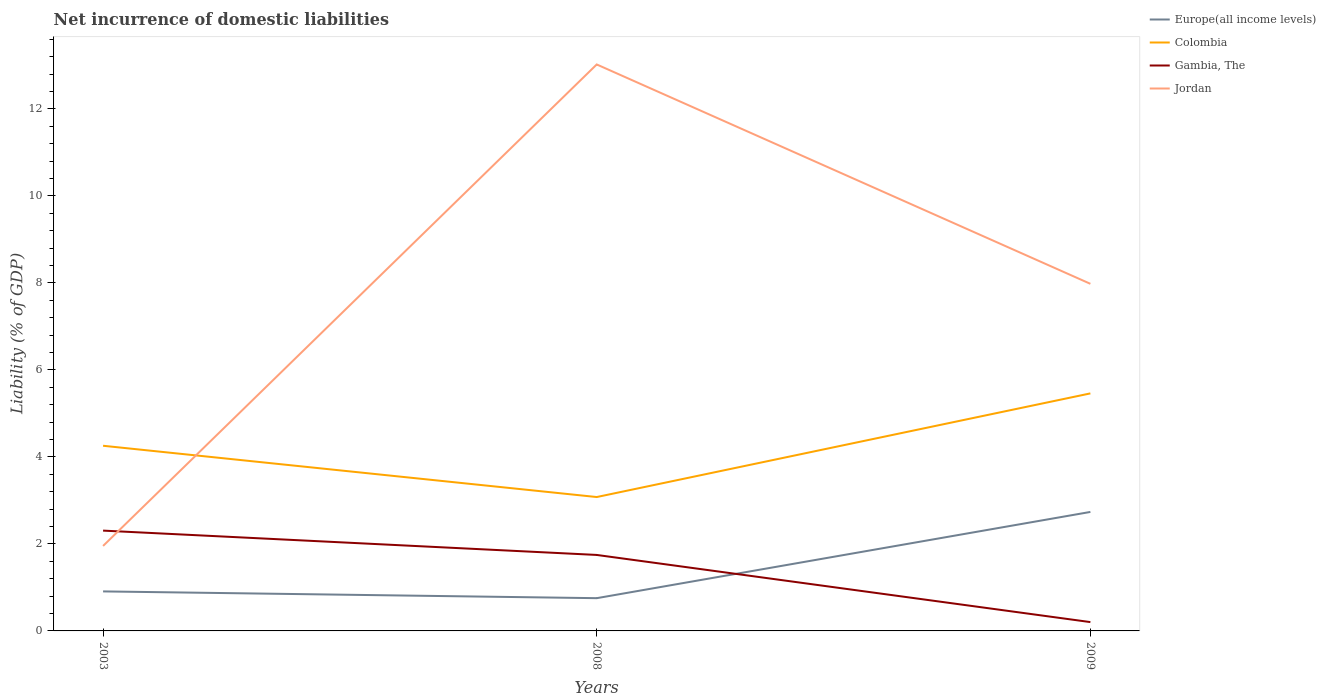Across all years, what is the maximum net incurrence of domestic liabilities in Jordan?
Your answer should be very brief. 1.95. In which year was the net incurrence of domestic liabilities in Jordan maximum?
Offer a terse response. 2003. What is the total net incurrence of domestic liabilities in Colombia in the graph?
Keep it short and to the point. 1.18. What is the difference between the highest and the second highest net incurrence of domestic liabilities in Colombia?
Your response must be concise. 2.38. Is the net incurrence of domestic liabilities in Europe(all income levels) strictly greater than the net incurrence of domestic liabilities in Jordan over the years?
Offer a terse response. Yes. Does the graph contain any zero values?
Keep it short and to the point. No. Where does the legend appear in the graph?
Your answer should be very brief. Top right. How many legend labels are there?
Offer a very short reply. 4. How are the legend labels stacked?
Give a very brief answer. Vertical. What is the title of the graph?
Ensure brevity in your answer.  Net incurrence of domestic liabilities. Does "Lower middle income" appear as one of the legend labels in the graph?
Make the answer very short. No. What is the label or title of the X-axis?
Keep it short and to the point. Years. What is the label or title of the Y-axis?
Make the answer very short. Liability (% of GDP). What is the Liability (% of GDP) in Europe(all income levels) in 2003?
Keep it short and to the point. 0.91. What is the Liability (% of GDP) in Colombia in 2003?
Your answer should be very brief. 4.26. What is the Liability (% of GDP) of Gambia, The in 2003?
Ensure brevity in your answer.  2.31. What is the Liability (% of GDP) in Jordan in 2003?
Ensure brevity in your answer.  1.95. What is the Liability (% of GDP) in Europe(all income levels) in 2008?
Your answer should be compact. 0.75. What is the Liability (% of GDP) of Colombia in 2008?
Make the answer very short. 3.08. What is the Liability (% of GDP) in Gambia, The in 2008?
Your answer should be very brief. 1.75. What is the Liability (% of GDP) of Jordan in 2008?
Offer a terse response. 13.02. What is the Liability (% of GDP) of Europe(all income levels) in 2009?
Your answer should be compact. 2.74. What is the Liability (% of GDP) of Colombia in 2009?
Your response must be concise. 5.46. What is the Liability (% of GDP) in Gambia, The in 2009?
Your response must be concise. 0.2. What is the Liability (% of GDP) of Jordan in 2009?
Keep it short and to the point. 7.98. Across all years, what is the maximum Liability (% of GDP) of Europe(all income levels)?
Offer a very short reply. 2.74. Across all years, what is the maximum Liability (% of GDP) of Colombia?
Provide a short and direct response. 5.46. Across all years, what is the maximum Liability (% of GDP) in Gambia, The?
Offer a very short reply. 2.31. Across all years, what is the maximum Liability (% of GDP) in Jordan?
Your response must be concise. 13.02. Across all years, what is the minimum Liability (% of GDP) in Europe(all income levels)?
Ensure brevity in your answer.  0.75. Across all years, what is the minimum Liability (% of GDP) of Colombia?
Ensure brevity in your answer.  3.08. Across all years, what is the minimum Liability (% of GDP) of Gambia, The?
Give a very brief answer. 0.2. Across all years, what is the minimum Liability (% of GDP) in Jordan?
Offer a very short reply. 1.95. What is the total Liability (% of GDP) of Europe(all income levels) in the graph?
Your answer should be compact. 4.4. What is the total Liability (% of GDP) in Colombia in the graph?
Provide a succinct answer. 12.8. What is the total Liability (% of GDP) in Gambia, The in the graph?
Offer a terse response. 4.26. What is the total Liability (% of GDP) in Jordan in the graph?
Your response must be concise. 22.96. What is the difference between the Liability (% of GDP) of Europe(all income levels) in 2003 and that in 2008?
Keep it short and to the point. 0.16. What is the difference between the Liability (% of GDP) in Colombia in 2003 and that in 2008?
Ensure brevity in your answer.  1.18. What is the difference between the Liability (% of GDP) of Gambia, The in 2003 and that in 2008?
Provide a short and direct response. 0.56. What is the difference between the Liability (% of GDP) in Jordan in 2003 and that in 2008?
Your answer should be compact. -11.07. What is the difference between the Liability (% of GDP) in Europe(all income levels) in 2003 and that in 2009?
Offer a very short reply. -1.83. What is the difference between the Liability (% of GDP) of Colombia in 2003 and that in 2009?
Provide a succinct answer. -1.2. What is the difference between the Liability (% of GDP) of Gambia, The in 2003 and that in 2009?
Make the answer very short. 2.1. What is the difference between the Liability (% of GDP) of Jordan in 2003 and that in 2009?
Provide a succinct answer. -6.03. What is the difference between the Liability (% of GDP) in Europe(all income levels) in 2008 and that in 2009?
Your answer should be compact. -1.98. What is the difference between the Liability (% of GDP) of Colombia in 2008 and that in 2009?
Offer a terse response. -2.38. What is the difference between the Liability (% of GDP) in Gambia, The in 2008 and that in 2009?
Your response must be concise. 1.54. What is the difference between the Liability (% of GDP) in Jordan in 2008 and that in 2009?
Give a very brief answer. 5.04. What is the difference between the Liability (% of GDP) of Europe(all income levels) in 2003 and the Liability (% of GDP) of Colombia in 2008?
Keep it short and to the point. -2.17. What is the difference between the Liability (% of GDP) in Europe(all income levels) in 2003 and the Liability (% of GDP) in Gambia, The in 2008?
Your answer should be very brief. -0.84. What is the difference between the Liability (% of GDP) of Europe(all income levels) in 2003 and the Liability (% of GDP) of Jordan in 2008?
Your response must be concise. -12.12. What is the difference between the Liability (% of GDP) of Colombia in 2003 and the Liability (% of GDP) of Gambia, The in 2008?
Provide a succinct answer. 2.51. What is the difference between the Liability (% of GDP) in Colombia in 2003 and the Liability (% of GDP) in Jordan in 2008?
Provide a short and direct response. -8.77. What is the difference between the Liability (% of GDP) of Gambia, The in 2003 and the Liability (% of GDP) of Jordan in 2008?
Provide a short and direct response. -10.72. What is the difference between the Liability (% of GDP) in Europe(all income levels) in 2003 and the Liability (% of GDP) in Colombia in 2009?
Provide a succinct answer. -4.55. What is the difference between the Liability (% of GDP) in Europe(all income levels) in 2003 and the Liability (% of GDP) in Gambia, The in 2009?
Offer a very short reply. 0.71. What is the difference between the Liability (% of GDP) of Europe(all income levels) in 2003 and the Liability (% of GDP) of Jordan in 2009?
Keep it short and to the point. -7.07. What is the difference between the Liability (% of GDP) in Colombia in 2003 and the Liability (% of GDP) in Gambia, The in 2009?
Provide a short and direct response. 4.05. What is the difference between the Liability (% of GDP) of Colombia in 2003 and the Liability (% of GDP) of Jordan in 2009?
Provide a succinct answer. -3.72. What is the difference between the Liability (% of GDP) of Gambia, The in 2003 and the Liability (% of GDP) of Jordan in 2009?
Make the answer very short. -5.67. What is the difference between the Liability (% of GDP) in Europe(all income levels) in 2008 and the Liability (% of GDP) in Colombia in 2009?
Make the answer very short. -4.71. What is the difference between the Liability (% of GDP) in Europe(all income levels) in 2008 and the Liability (% of GDP) in Gambia, The in 2009?
Your answer should be very brief. 0.55. What is the difference between the Liability (% of GDP) of Europe(all income levels) in 2008 and the Liability (% of GDP) of Jordan in 2009?
Ensure brevity in your answer.  -7.23. What is the difference between the Liability (% of GDP) in Colombia in 2008 and the Liability (% of GDP) in Gambia, The in 2009?
Your response must be concise. 2.88. What is the difference between the Liability (% of GDP) of Colombia in 2008 and the Liability (% of GDP) of Jordan in 2009?
Provide a short and direct response. -4.9. What is the difference between the Liability (% of GDP) of Gambia, The in 2008 and the Liability (% of GDP) of Jordan in 2009?
Your answer should be very brief. -6.23. What is the average Liability (% of GDP) in Europe(all income levels) per year?
Give a very brief answer. 1.47. What is the average Liability (% of GDP) in Colombia per year?
Your answer should be very brief. 4.27. What is the average Liability (% of GDP) in Gambia, The per year?
Provide a short and direct response. 1.42. What is the average Liability (% of GDP) in Jordan per year?
Keep it short and to the point. 7.65. In the year 2003, what is the difference between the Liability (% of GDP) of Europe(all income levels) and Liability (% of GDP) of Colombia?
Your answer should be compact. -3.35. In the year 2003, what is the difference between the Liability (% of GDP) of Europe(all income levels) and Liability (% of GDP) of Gambia, The?
Provide a succinct answer. -1.4. In the year 2003, what is the difference between the Liability (% of GDP) in Europe(all income levels) and Liability (% of GDP) in Jordan?
Offer a terse response. -1.05. In the year 2003, what is the difference between the Liability (% of GDP) in Colombia and Liability (% of GDP) in Gambia, The?
Offer a terse response. 1.95. In the year 2003, what is the difference between the Liability (% of GDP) in Colombia and Liability (% of GDP) in Jordan?
Your answer should be very brief. 2.3. In the year 2003, what is the difference between the Liability (% of GDP) of Gambia, The and Liability (% of GDP) of Jordan?
Your response must be concise. 0.35. In the year 2008, what is the difference between the Liability (% of GDP) in Europe(all income levels) and Liability (% of GDP) in Colombia?
Your answer should be compact. -2.33. In the year 2008, what is the difference between the Liability (% of GDP) in Europe(all income levels) and Liability (% of GDP) in Gambia, The?
Provide a succinct answer. -0.99. In the year 2008, what is the difference between the Liability (% of GDP) in Europe(all income levels) and Liability (% of GDP) in Jordan?
Offer a terse response. -12.27. In the year 2008, what is the difference between the Liability (% of GDP) in Colombia and Liability (% of GDP) in Gambia, The?
Provide a short and direct response. 1.33. In the year 2008, what is the difference between the Liability (% of GDP) of Colombia and Liability (% of GDP) of Jordan?
Your response must be concise. -9.95. In the year 2008, what is the difference between the Liability (% of GDP) in Gambia, The and Liability (% of GDP) in Jordan?
Make the answer very short. -11.28. In the year 2009, what is the difference between the Liability (% of GDP) in Europe(all income levels) and Liability (% of GDP) in Colombia?
Your answer should be very brief. -2.73. In the year 2009, what is the difference between the Liability (% of GDP) of Europe(all income levels) and Liability (% of GDP) of Gambia, The?
Provide a succinct answer. 2.53. In the year 2009, what is the difference between the Liability (% of GDP) of Europe(all income levels) and Liability (% of GDP) of Jordan?
Your response must be concise. -5.24. In the year 2009, what is the difference between the Liability (% of GDP) in Colombia and Liability (% of GDP) in Gambia, The?
Give a very brief answer. 5.26. In the year 2009, what is the difference between the Liability (% of GDP) in Colombia and Liability (% of GDP) in Jordan?
Provide a short and direct response. -2.52. In the year 2009, what is the difference between the Liability (% of GDP) of Gambia, The and Liability (% of GDP) of Jordan?
Offer a terse response. -7.78. What is the ratio of the Liability (% of GDP) in Europe(all income levels) in 2003 to that in 2008?
Make the answer very short. 1.21. What is the ratio of the Liability (% of GDP) in Colombia in 2003 to that in 2008?
Your response must be concise. 1.38. What is the ratio of the Liability (% of GDP) in Gambia, The in 2003 to that in 2008?
Provide a succinct answer. 1.32. What is the ratio of the Liability (% of GDP) in Europe(all income levels) in 2003 to that in 2009?
Your answer should be compact. 0.33. What is the ratio of the Liability (% of GDP) of Colombia in 2003 to that in 2009?
Your response must be concise. 0.78. What is the ratio of the Liability (% of GDP) in Gambia, The in 2003 to that in 2009?
Your answer should be compact. 11.37. What is the ratio of the Liability (% of GDP) of Jordan in 2003 to that in 2009?
Provide a succinct answer. 0.24. What is the ratio of the Liability (% of GDP) of Europe(all income levels) in 2008 to that in 2009?
Offer a terse response. 0.28. What is the ratio of the Liability (% of GDP) in Colombia in 2008 to that in 2009?
Your answer should be very brief. 0.56. What is the ratio of the Liability (% of GDP) in Gambia, The in 2008 to that in 2009?
Provide a short and direct response. 8.61. What is the ratio of the Liability (% of GDP) in Jordan in 2008 to that in 2009?
Provide a succinct answer. 1.63. What is the difference between the highest and the second highest Liability (% of GDP) of Europe(all income levels)?
Provide a succinct answer. 1.83. What is the difference between the highest and the second highest Liability (% of GDP) of Colombia?
Offer a terse response. 1.2. What is the difference between the highest and the second highest Liability (% of GDP) in Gambia, The?
Offer a very short reply. 0.56. What is the difference between the highest and the second highest Liability (% of GDP) in Jordan?
Your answer should be compact. 5.04. What is the difference between the highest and the lowest Liability (% of GDP) in Europe(all income levels)?
Offer a very short reply. 1.98. What is the difference between the highest and the lowest Liability (% of GDP) in Colombia?
Provide a succinct answer. 2.38. What is the difference between the highest and the lowest Liability (% of GDP) in Gambia, The?
Offer a very short reply. 2.1. What is the difference between the highest and the lowest Liability (% of GDP) of Jordan?
Keep it short and to the point. 11.07. 